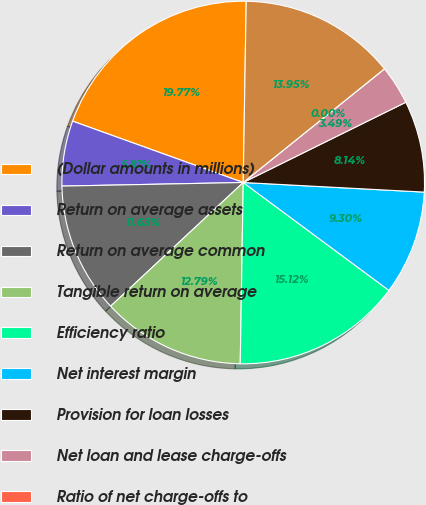Convert chart. <chart><loc_0><loc_0><loc_500><loc_500><pie_chart><fcel>(Dollar amounts in millions)<fcel>Return on average assets<fcel>Return on average common<fcel>Tangible return on average<fcel>Efficiency ratio<fcel>Net interest margin<fcel>Provision for loan losses<fcel>Net loan and lease charge-offs<fcel>Ratio of net charge-offs to<fcel>Allowance for loan losses<nl><fcel>19.77%<fcel>5.81%<fcel>11.63%<fcel>12.79%<fcel>15.12%<fcel>9.3%<fcel>8.14%<fcel>3.49%<fcel>0.0%<fcel>13.95%<nl></chart> 